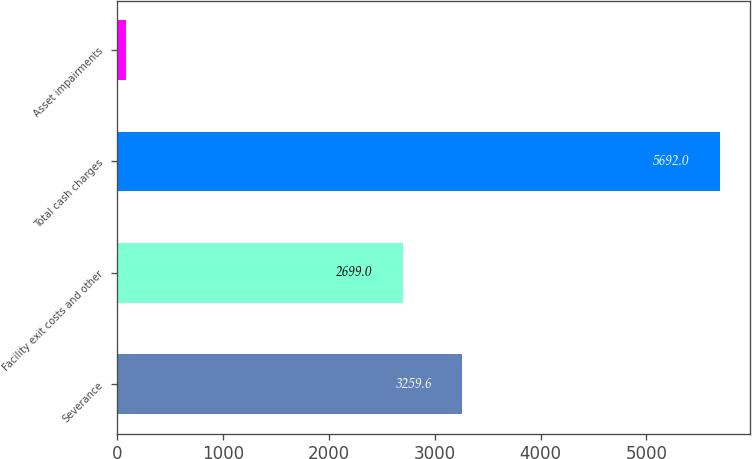Convert chart. <chart><loc_0><loc_0><loc_500><loc_500><bar_chart><fcel>Severance<fcel>Facility exit costs and other<fcel>Total cash charges<fcel>Asset impairments<nl><fcel>3259.6<fcel>2699<fcel>5692<fcel>86<nl></chart> 